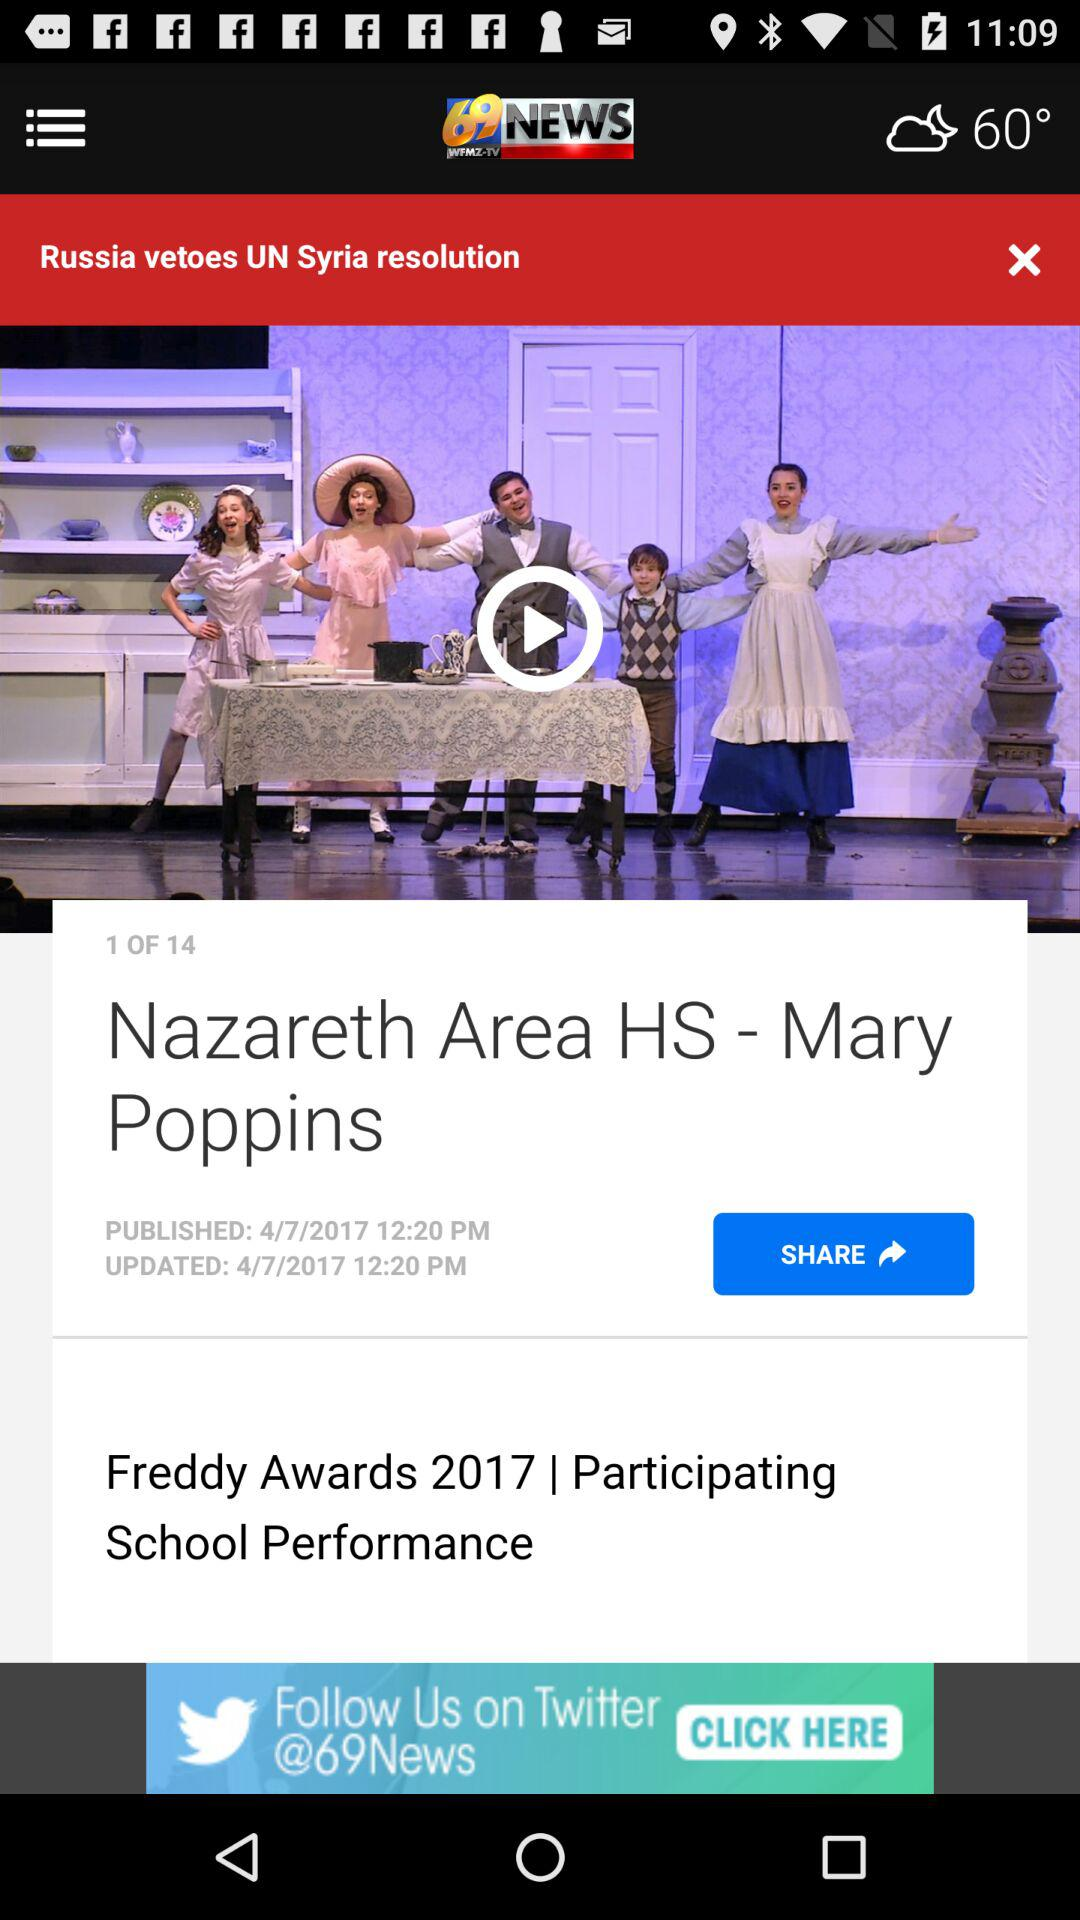How many people liked "Nazareth Area HS - Mary Poppins"?
When the provided information is insufficient, respond with <no answer>. <no answer> 